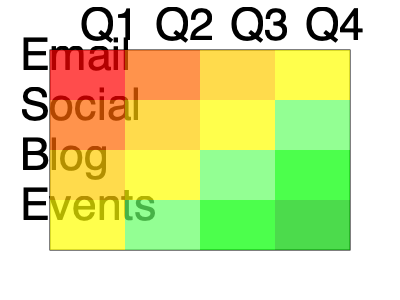Based on the heat map of customer engagement levels across various marketing channels, which channel shows the most significant improvement in engagement from Q1 to Q4, and how might this inform future marketing strategies for the curated collections? To answer this question, we need to analyze the heat map systematically:

1. Understand the heat map:
   - Rows represent marketing channels: Email, Social, Blog, Events
   - Columns represent quarters: Q1, Q2, Q3, Q4
   - Colors indicate engagement levels: Red (low) to Green (high)

2. Analyze each channel's progression from Q1 to Q4:
   - Email: Red → Orange → Yellow → Yellow (Slight improvement)
   - Social: Orange → Yellow → Yellow → Light Green (Moderate improvement)
   - Blog: Yellow → Yellow → Light Green → Green (Significant improvement)
   - Events: Yellow → Light Green → Green → Dark Green (Most significant improvement)

3. Identify the channel with the most significant improvement:
   - Events show the most dramatic color change from Yellow (Q1) to Dark Green (Q4)

4. Interpret the results:
   - Events have become increasingly effective in engaging customers throughout the year
   - This suggests that in-person or virtual events are resonating well with the loyal customer base

5. Consider future marketing strategies:
   - Increase focus on event-based marketing for curated collections
   - Potentially allocate more resources to event planning and execution
   - Use events as a platform to showcase new collections and gather immediate feedback
   - Integrate learnings from successful events into other marketing channels

6. Address the persona:
   - As loyal customers who provide valuable feedback, they likely appreciate the interactive nature of events
   - Events offer opportunities for these customers to engage directly with new collections and provide real-time feedback
Answer: Events channel; increase event-based marketing for curated collections. 